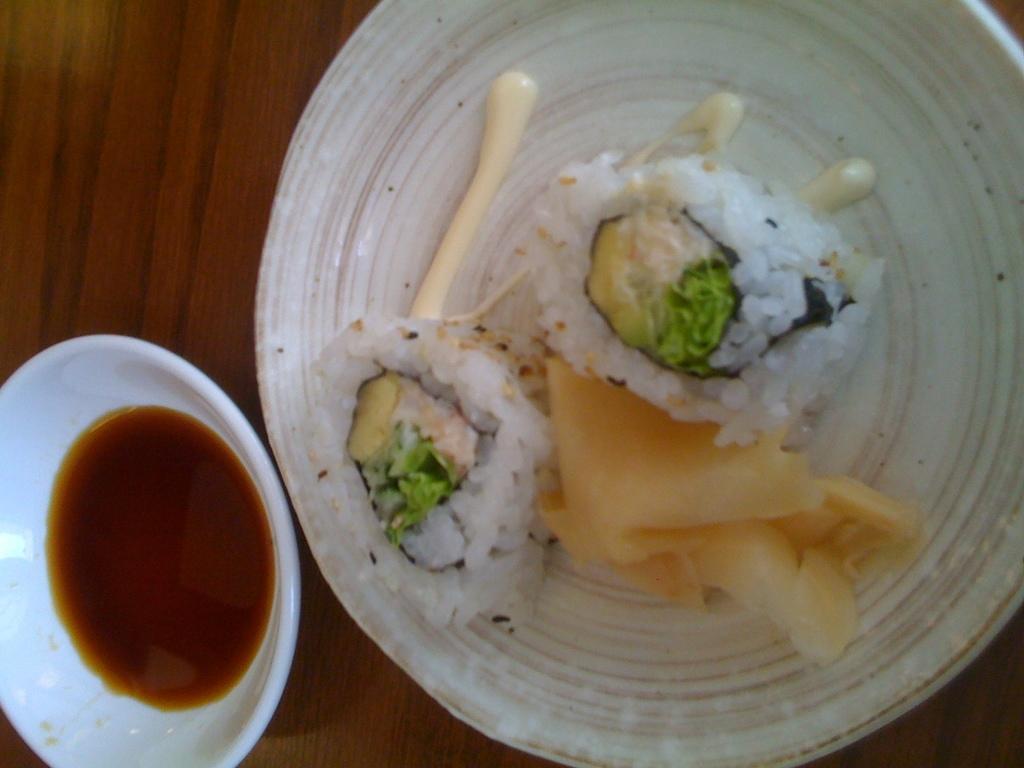Describe this image in one or two sentences. This is a zoomed in picture. In the center there is a wooden table on the top of which a white color platter containing sushi and some other food items is placed and we can see a white color bowl containing some liquid is placed on the top of the table. 